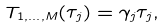Convert formula to latex. <formula><loc_0><loc_0><loc_500><loc_500>T _ { 1 , \dots , M } ( \tau _ { j } ) = \gamma _ { j } \tau _ { j } ,</formula> 